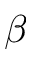Convert formula to latex. <formula><loc_0><loc_0><loc_500><loc_500>\beta</formula> 